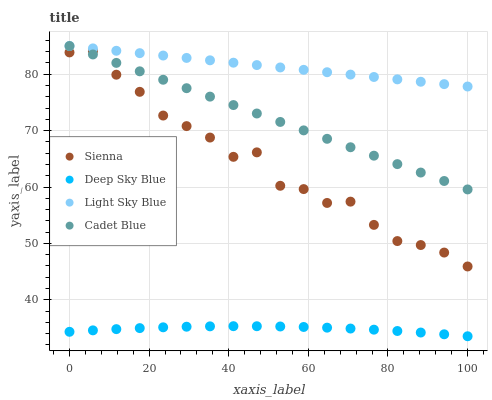Does Deep Sky Blue have the minimum area under the curve?
Answer yes or no. Yes. Does Light Sky Blue have the maximum area under the curve?
Answer yes or no. Yes. Does Cadet Blue have the minimum area under the curve?
Answer yes or no. No. Does Cadet Blue have the maximum area under the curve?
Answer yes or no. No. Is Light Sky Blue the smoothest?
Answer yes or no. Yes. Is Sienna the roughest?
Answer yes or no. Yes. Is Cadet Blue the smoothest?
Answer yes or no. No. Is Cadet Blue the roughest?
Answer yes or no. No. Does Deep Sky Blue have the lowest value?
Answer yes or no. Yes. Does Cadet Blue have the lowest value?
Answer yes or no. No. Does Cadet Blue have the highest value?
Answer yes or no. Yes. Does Deep Sky Blue have the highest value?
Answer yes or no. No. Is Deep Sky Blue less than Light Sky Blue?
Answer yes or no. Yes. Is Light Sky Blue greater than Deep Sky Blue?
Answer yes or no. Yes. Does Cadet Blue intersect Sienna?
Answer yes or no. Yes. Is Cadet Blue less than Sienna?
Answer yes or no. No. Is Cadet Blue greater than Sienna?
Answer yes or no. No. Does Deep Sky Blue intersect Light Sky Blue?
Answer yes or no. No. 